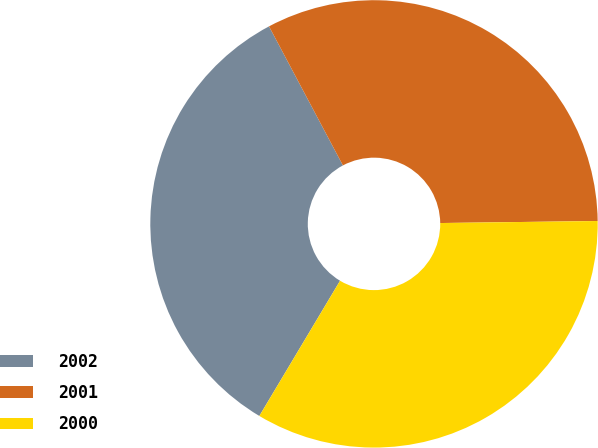<chart> <loc_0><loc_0><loc_500><loc_500><pie_chart><fcel>2002<fcel>2001<fcel>2000<nl><fcel>33.66%<fcel>32.57%<fcel>33.77%<nl></chart> 